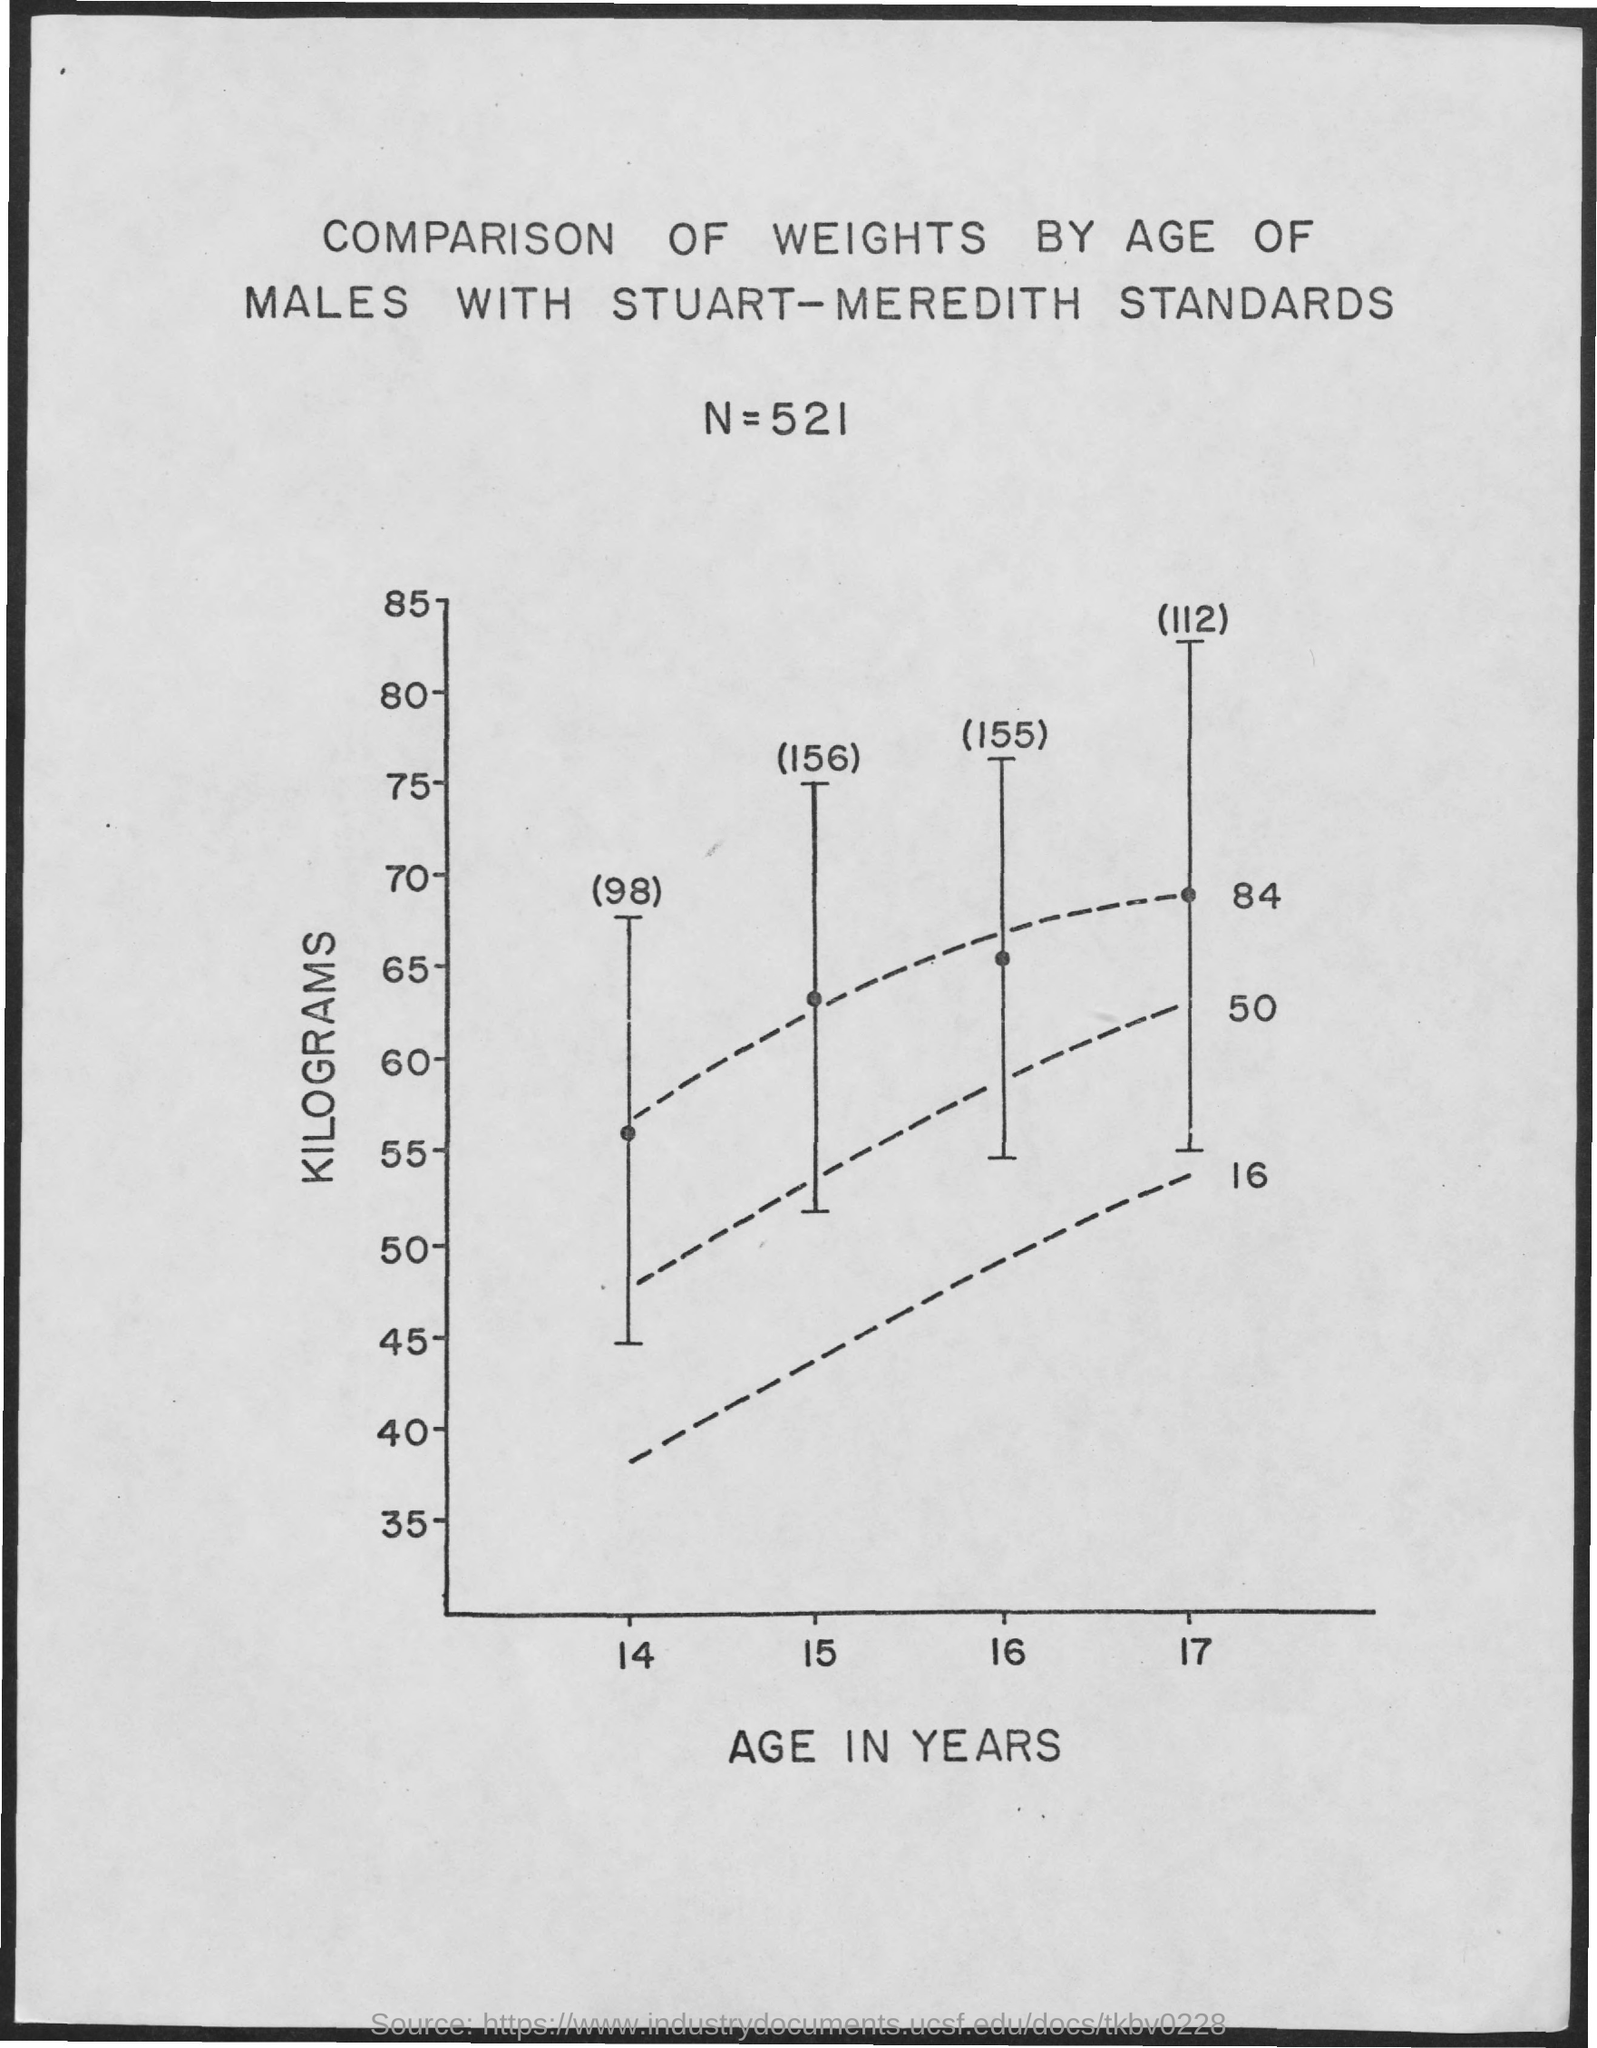What is the title?
Your answer should be compact. Comparison of weights by age of males with stuart-meredith standards. What is the value of n?
Your answer should be compact. 521. What does the y-axis represent?
Offer a terse response. Kilograms. What does the x-axis represent?
Your answer should be very brief. Age in years. 